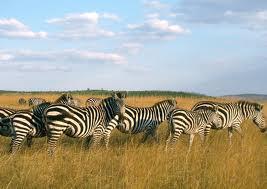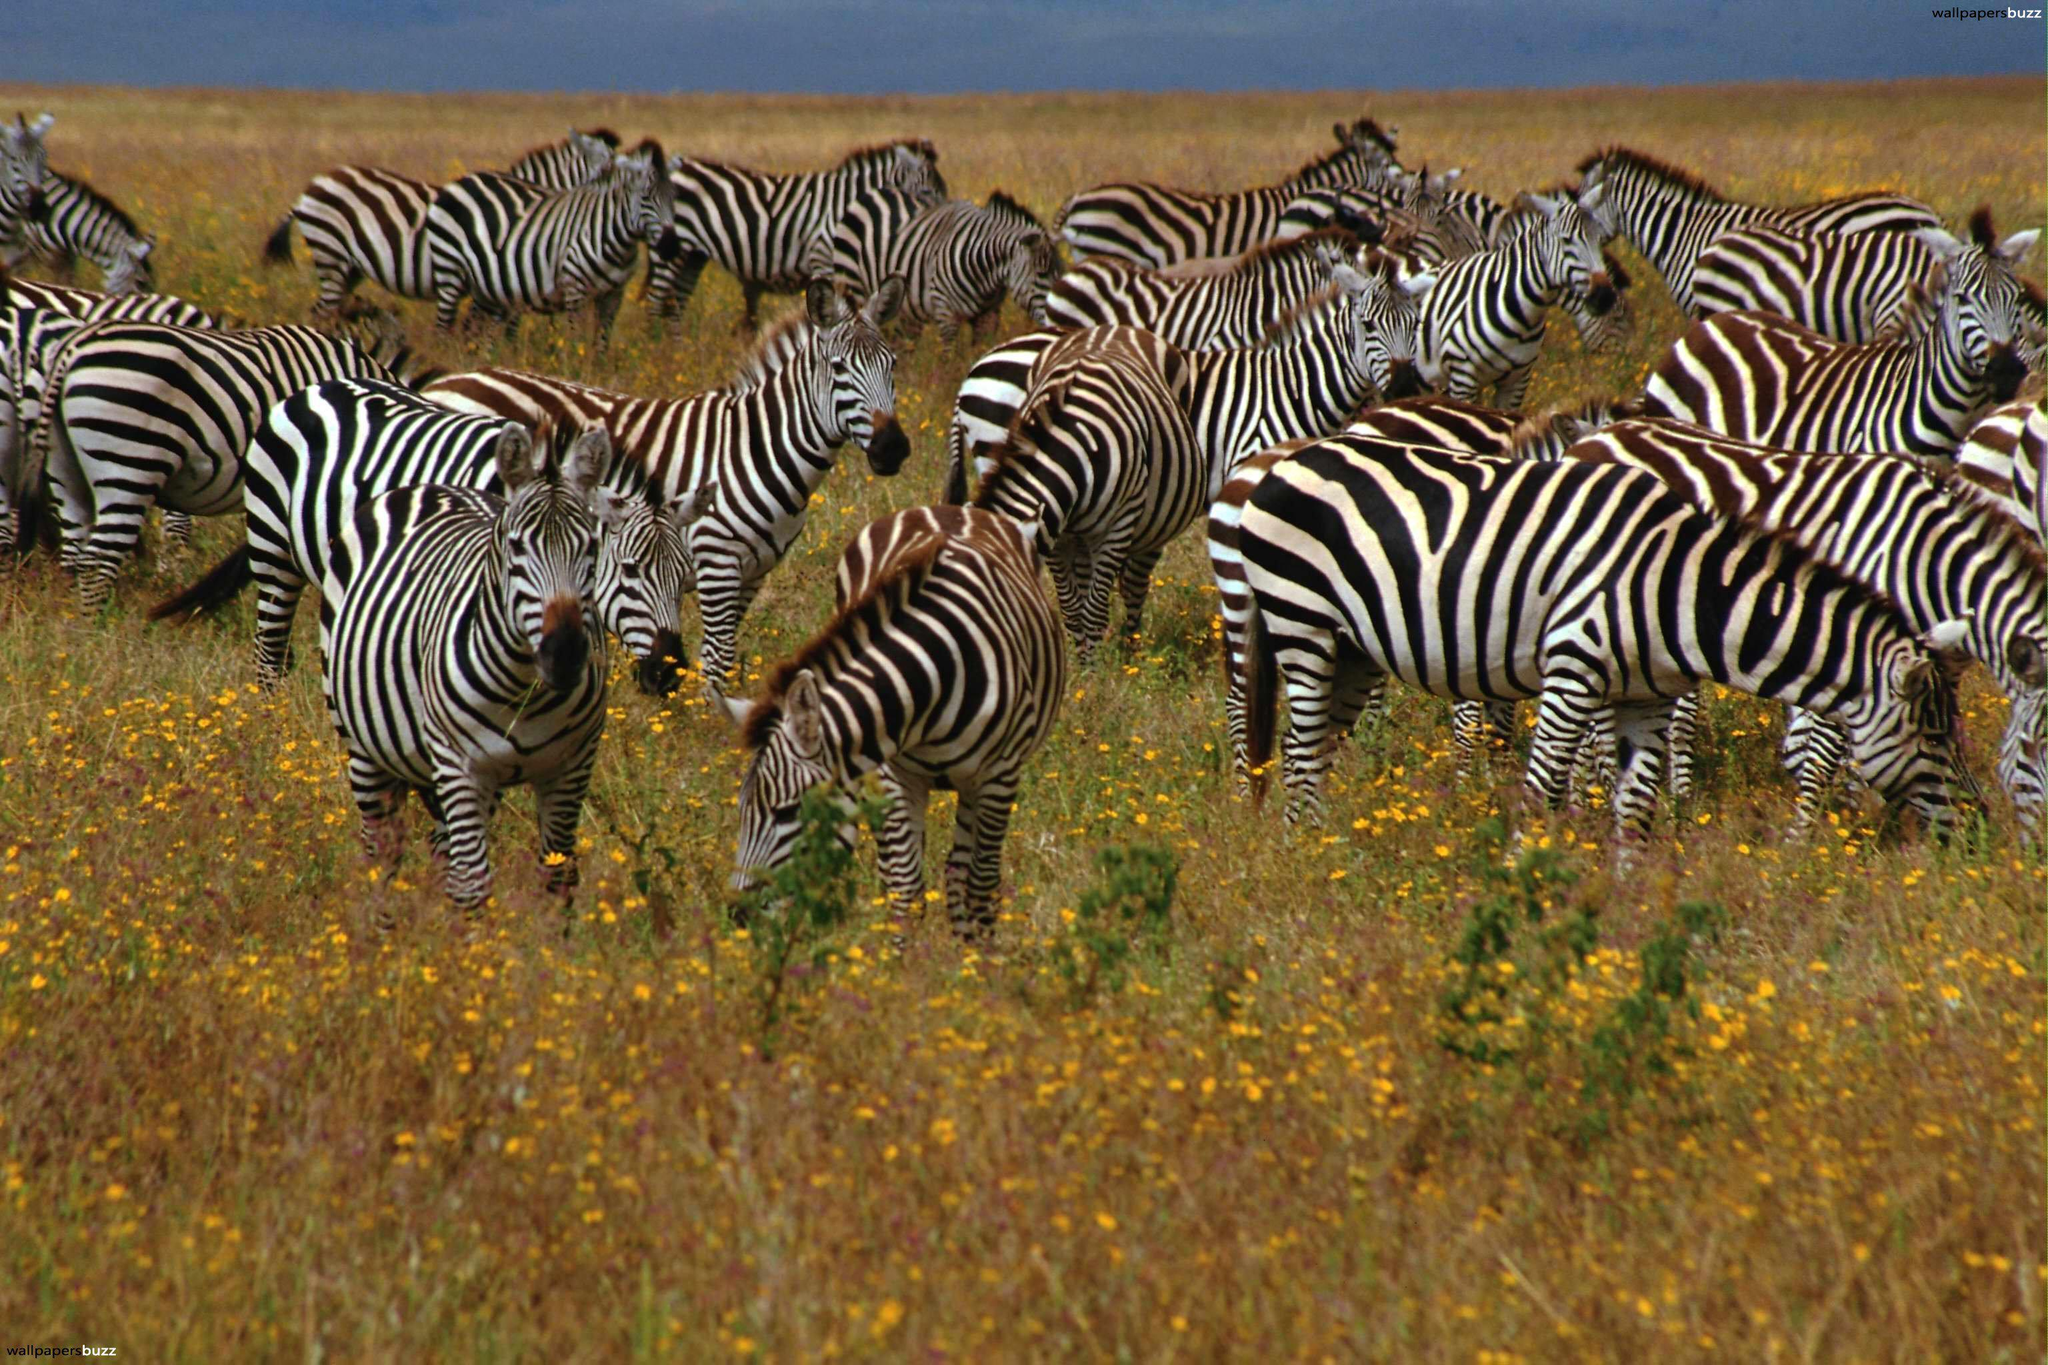The first image is the image on the left, the second image is the image on the right. Analyze the images presented: Is the assertion "The right image features a row of zebras with their bodies facing rightward." valid? Answer yes or no. No. The first image is the image on the left, the second image is the image on the right. Examine the images to the left and right. Is the description "In at least one image is a row of zebra going right and in the other image there is is a large group of zebra in different directions." accurate? Answer yes or no. Yes. 